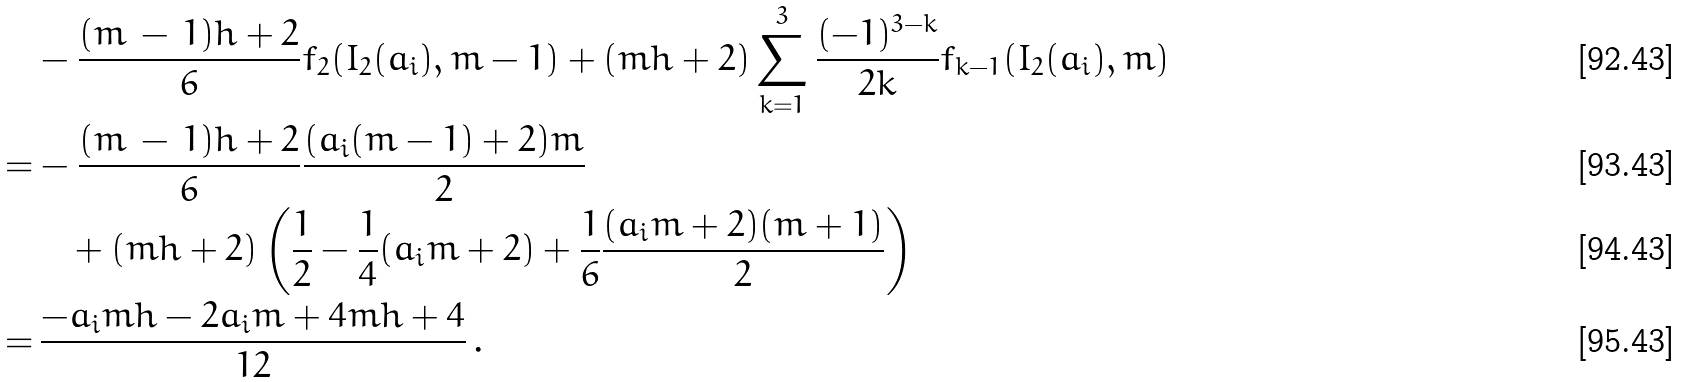<formula> <loc_0><loc_0><loc_500><loc_500>& - \frac { ( m \, - \, 1 ) h + 2 } { 6 } f _ { 2 } ( I _ { 2 } ( a _ { i } ) , m - 1 ) + ( m h + 2 ) \sum _ { k = 1 } ^ { 3 } \frac { ( - 1 ) ^ { 3 - k } } { 2 k } f _ { k - 1 } ( I _ { 2 } ( a _ { i } ) , m ) \\ = & - \frac { ( m \, - \, 1 ) h + 2 } { 6 } \frac { ( a _ { i } ( m - 1 ) + 2 ) m } { 2 } \\ & \quad + ( m h + 2 ) \left ( \frac { 1 } { 2 } - \frac { 1 } { 4 } ( a _ { i } m + 2 ) + \frac { 1 } { 6 } \frac { ( a _ { i } m + 2 ) ( m + 1 ) } { 2 } \right ) \\ = & \, \frac { - a _ { i } m h - 2 a _ { i } m + 4 m h + 4 } { 1 2 } \, .</formula> 